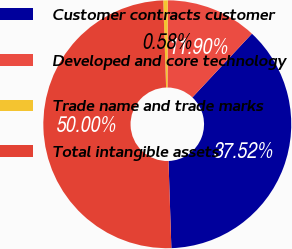<chart> <loc_0><loc_0><loc_500><loc_500><pie_chart><fcel>Customer contracts customer<fcel>Developed and core technology<fcel>Trade name and trade marks<fcel>Total intangible assets<nl><fcel>37.52%<fcel>11.9%<fcel>0.58%<fcel>50.0%<nl></chart> 